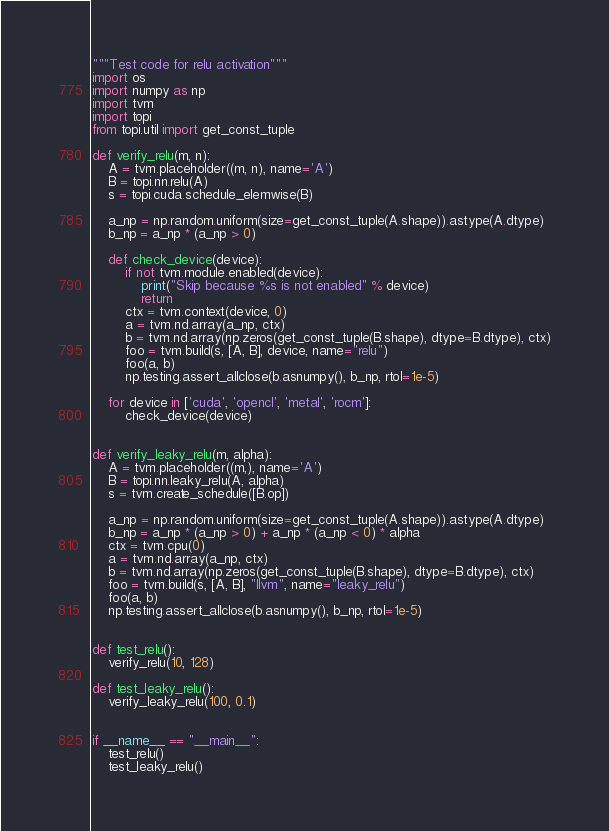Convert code to text. <code><loc_0><loc_0><loc_500><loc_500><_Python_>"""Test code for relu activation"""
import os
import numpy as np
import tvm
import topi
from topi.util import get_const_tuple

def verify_relu(m, n):
    A = tvm.placeholder((m, n), name='A')
    B = topi.nn.relu(A)
    s = topi.cuda.schedule_elemwise(B)

    a_np = np.random.uniform(size=get_const_tuple(A.shape)).astype(A.dtype)
    b_np = a_np * (a_np > 0)

    def check_device(device):
        if not tvm.module.enabled(device):
            print("Skip because %s is not enabled" % device)
            return
        ctx = tvm.context(device, 0)
        a = tvm.nd.array(a_np, ctx)
        b = tvm.nd.array(np.zeros(get_const_tuple(B.shape), dtype=B.dtype), ctx)
        foo = tvm.build(s, [A, B], device, name="relu")
        foo(a, b)
        np.testing.assert_allclose(b.asnumpy(), b_np, rtol=1e-5)

    for device in ['cuda', 'opencl', 'metal', 'rocm']:
        check_device(device)


def verify_leaky_relu(m, alpha):
    A = tvm.placeholder((m,), name='A')
    B = topi.nn.leaky_relu(A, alpha)
    s = tvm.create_schedule([B.op])

    a_np = np.random.uniform(size=get_const_tuple(A.shape)).astype(A.dtype)
    b_np = a_np * (a_np > 0) + a_np * (a_np < 0) * alpha
    ctx = tvm.cpu(0)
    a = tvm.nd.array(a_np, ctx)
    b = tvm.nd.array(np.zeros(get_const_tuple(B.shape), dtype=B.dtype), ctx)
    foo = tvm.build(s, [A, B], "llvm", name="leaky_relu")
    foo(a, b)
    np.testing.assert_allclose(b.asnumpy(), b_np, rtol=1e-5)


def test_relu():
    verify_relu(10, 128)

def test_leaky_relu():
    verify_leaky_relu(100, 0.1)


if __name__ == "__main__":
    test_relu()
    test_leaky_relu()
</code> 